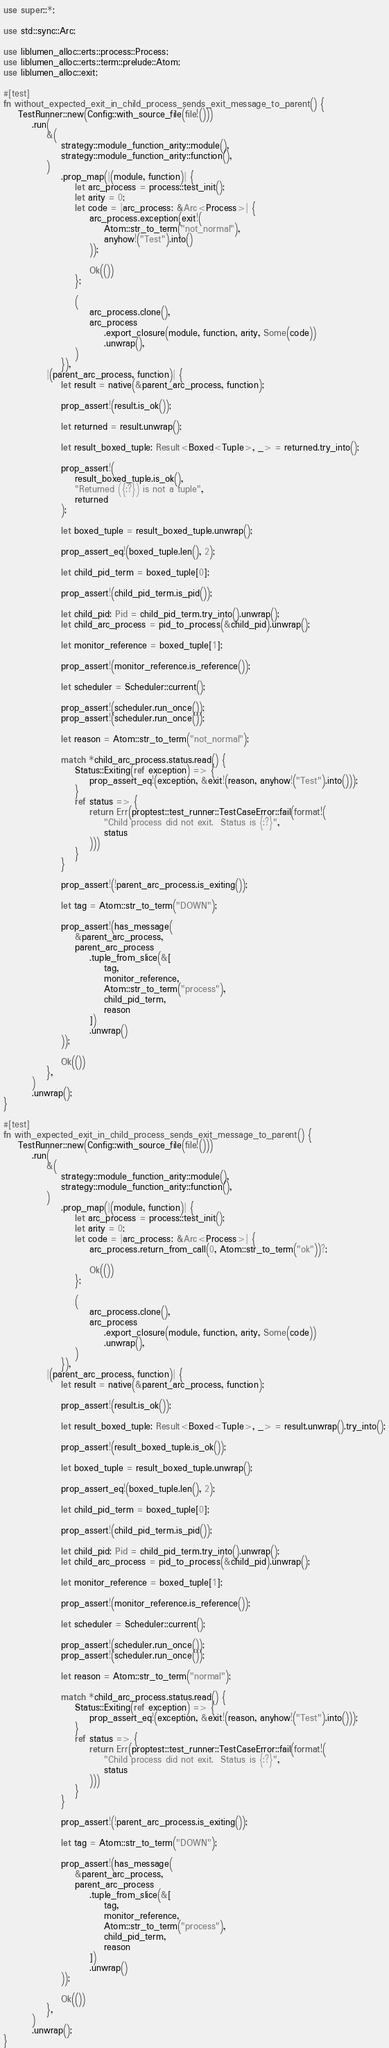<code> <loc_0><loc_0><loc_500><loc_500><_Rust_>use super::*;

use std::sync::Arc;

use liblumen_alloc::erts::process::Process;
use liblumen_alloc::erts::term::prelude::Atom;
use liblumen_alloc::exit;

#[test]
fn without_expected_exit_in_child_process_sends_exit_message_to_parent() {
    TestRunner::new(Config::with_source_file(file!()))
        .run(
            &(
                strategy::module_function_arity::module(),
                strategy::module_function_arity::function(),
            )
                .prop_map(|(module, function)| {
                    let arc_process = process::test_init();
                    let arity = 0;
                    let code = |arc_process: &Arc<Process>| {
                        arc_process.exception(exit!(
                            Atom::str_to_term("not_normal"),
                            anyhow!("Test").into()
                        ));

                        Ok(())
                    };

                    (
                        arc_process.clone(),
                        arc_process
                            .export_closure(module, function, arity, Some(code))
                            .unwrap(),
                    )
                }),
            |(parent_arc_process, function)| {
                let result = native(&parent_arc_process, function);

                prop_assert!(result.is_ok());

                let returned = result.unwrap();

                let result_boxed_tuple: Result<Boxed<Tuple>, _> = returned.try_into();

                prop_assert!(
                    result_boxed_tuple.is_ok(),
                    "Returned ({:?}) is not a tuple",
                    returned
                );

                let boxed_tuple = result_boxed_tuple.unwrap();

                prop_assert_eq!(boxed_tuple.len(), 2);

                let child_pid_term = boxed_tuple[0];

                prop_assert!(child_pid_term.is_pid());

                let child_pid: Pid = child_pid_term.try_into().unwrap();
                let child_arc_process = pid_to_process(&child_pid).unwrap();

                let monitor_reference = boxed_tuple[1];

                prop_assert!(monitor_reference.is_reference());

                let scheduler = Scheduler::current();

                prop_assert!(scheduler.run_once());
                prop_assert!(scheduler.run_once());

                let reason = Atom::str_to_term("not_normal");

                match *child_arc_process.status.read() {
                    Status::Exiting(ref exception) => {
                        prop_assert_eq!(exception, &exit!(reason, anyhow!("Test").into()));
                    }
                    ref status => {
                        return Err(proptest::test_runner::TestCaseError::fail(format!(
                            "Child process did not exit.  Status is {:?}",
                            status
                        )))
                    }
                }

                prop_assert!(!parent_arc_process.is_exiting());

                let tag = Atom::str_to_term("DOWN");

                prop_assert!(has_message(
                    &parent_arc_process,
                    parent_arc_process
                        .tuple_from_slice(&[
                            tag,
                            monitor_reference,
                            Atom::str_to_term("process"),
                            child_pid_term,
                            reason
                        ])
                        .unwrap()
                ));

                Ok(())
            },
        )
        .unwrap();
}

#[test]
fn with_expected_exit_in_child_process_sends_exit_message_to_parent() {
    TestRunner::new(Config::with_source_file(file!()))
        .run(
            &(
                strategy::module_function_arity::module(),
                strategy::module_function_arity::function(),
            )
                .prop_map(|(module, function)| {
                    let arc_process = process::test_init();
                    let arity = 0;
                    let code = |arc_process: &Arc<Process>| {
                        arc_process.return_from_call(0, Atom::str_to_term("ok"))?;

                        Ok(())
                    };

                    (
                        arc_process.clone(),
                        arc_process
                            .export_closure(module, function, arity, Some(code))
                            .unwrap(),
                    )
                }),
            |(parent_arc_process, function)| {
                let result = native(&parent_arc_process, function);

                prop_assert!(result.is_ok());

                let result_boxed_tuple: Result<Boxed<Tuple>, _> = result.unwrap().try_into();

                prop_assert!(result_boxed_tuple.is_ok());

                let boxed_tuple = result_boxed_tuple.unwrap();

                prop_assert_eq!(boxed_tuple.len(), 2);

                let child_pid_term = boxed_tuple[0];

                prop_assert!(child_pid_term.is_pid());

                let child_pid: Pid = child_pid_term.try_into().unwrap();
                let child_arc_process = pid_to_process(&child_pid).unwrap();

                let monitor_reference = boxed_tuple[1];

                prop_assert!(monitor_reference.is_reference());

                let scheduler = Scheduler::current();

                prop_assert!(scheduler.run_once());
                prop_assert!(scheduler.run_once());

                let reason = Atom::str_to_term("normal");

                match *child_arc_process.status.read() {
                    Status::Exiting(ref exception) => {
                        prop_assert_eq!(exception, &exit!(reason, anyhow!("Test").into()));
                    }
                    ref status => {
                        return Err(proptest::test_runner::TestCaseError::fail(format!(
                            "Child process did not exit.  Status is {:?}",
                            status
                        )))
                    }
                }

                prop_assert!(!parent_arc_process.is_exiting());

                let tag = Atom::str_to_term("DOWN");

                prop_assert!(has_message(
                    &parent_arc_process,
                    parent_arc_process
                        .tuple_from_slice(&[
                            tag,
                            monitor_reference,
                            Atom::str_to_term("process"),
                            child_pid_term,
                            reason
                        ])
                        .unwrap()
                ));

                Ok(())
            },
        )
        .unwrap();
}
</code> 